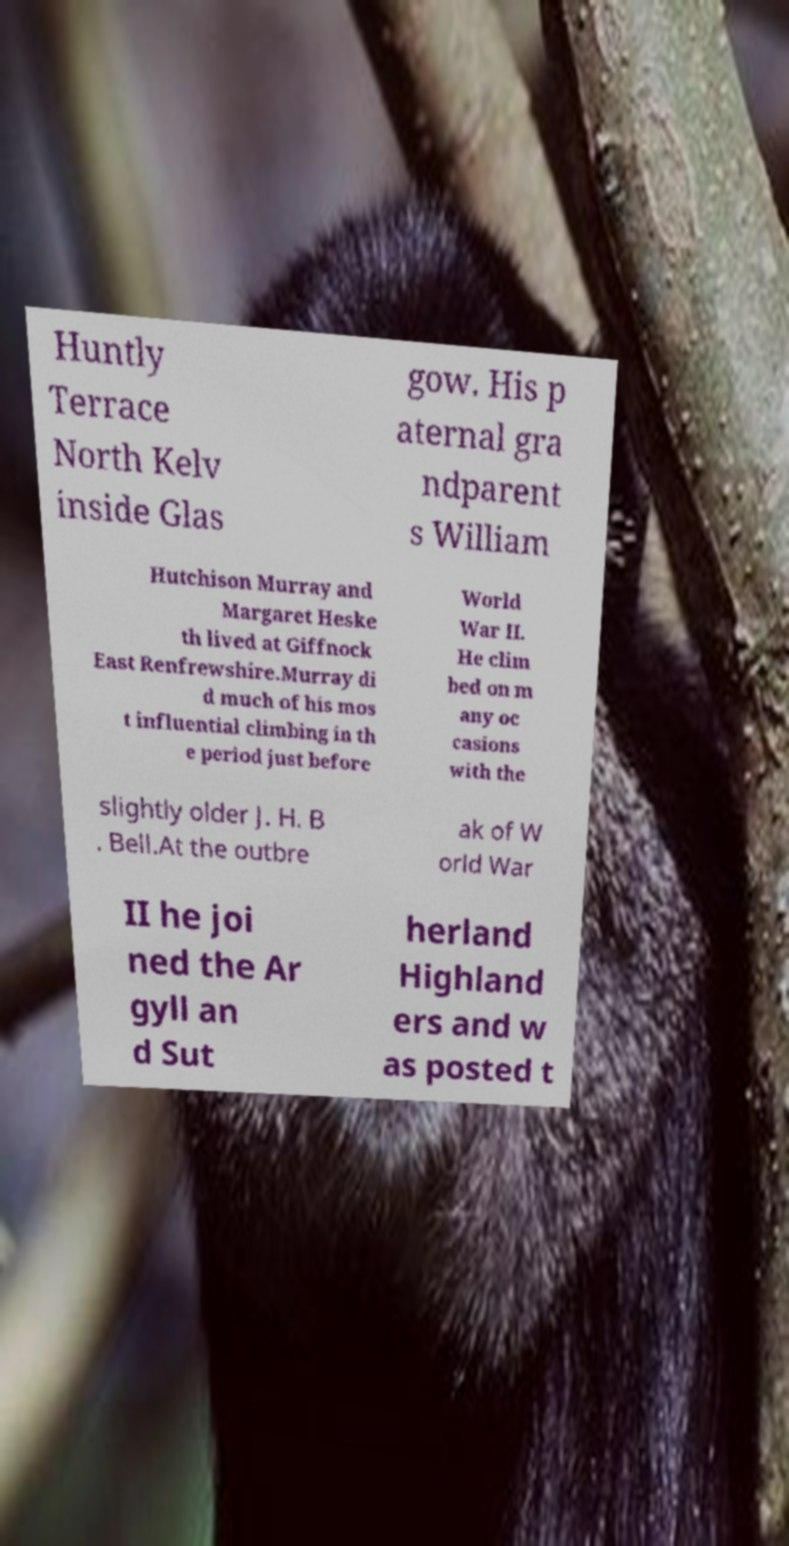What messages or text are displayed in this image? I need them in a readable, typed format. Huntly Terrace North Kelv inside Glas gow. His p aternal gra ndparent s William Hutchison Murray and Margaret Heske th lived at Giffnock East Renfrewshire.Murray di d much of his mos t influential climbing in th e period just before World War II. He clim bed on m any oc casions with the slightly older J. H. B . Bell.At the outbre ak of W orld War II he joi ned the Ar gyll an d Sut herland Highland ers and w as posted t 